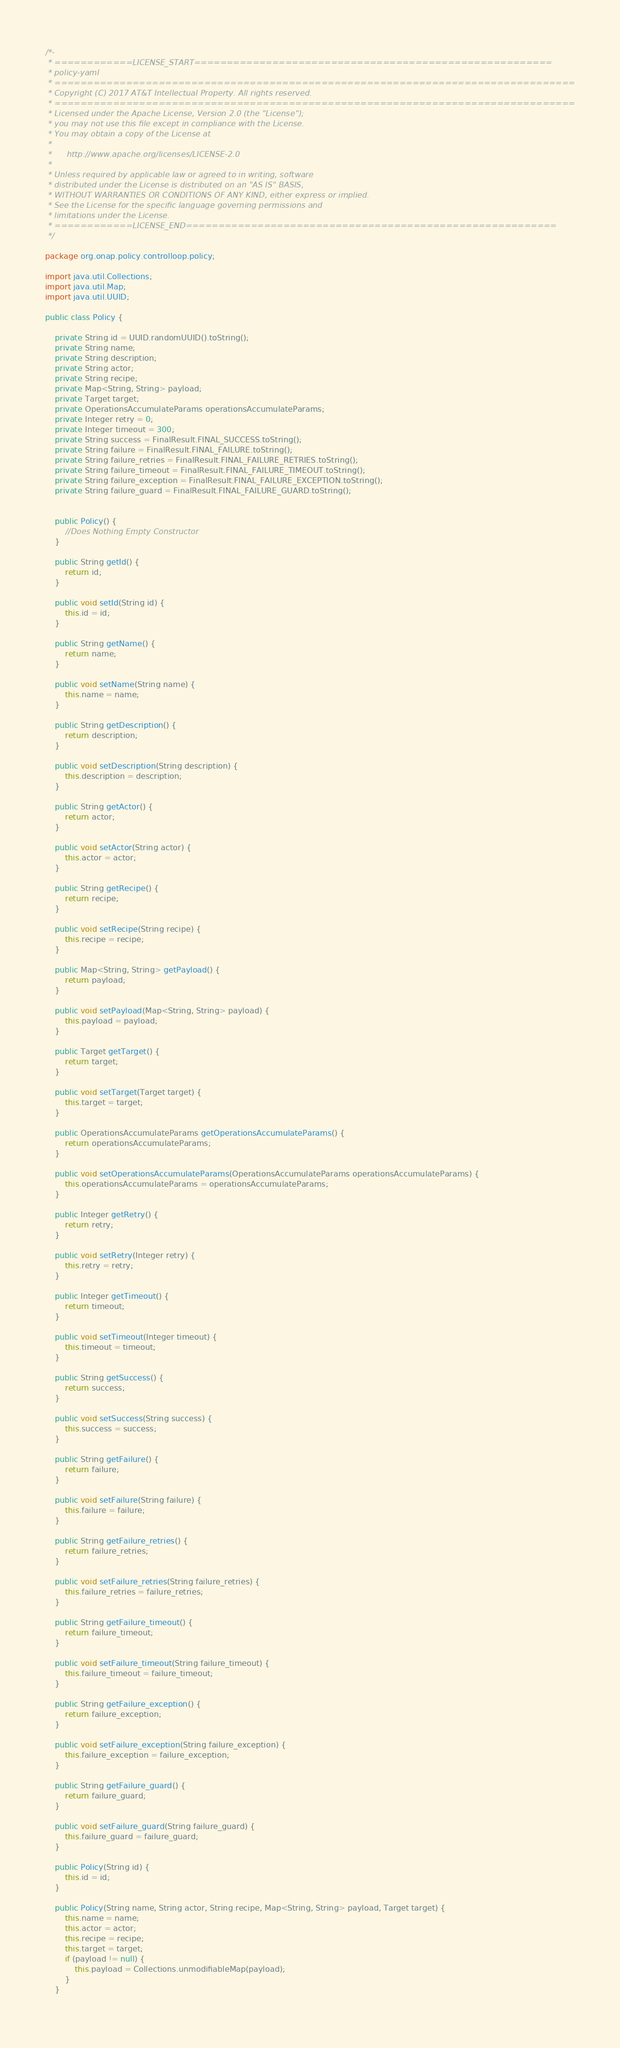<code> <loc_0><loc_0><loc_500><loc_500><_Java_>/*-
 * ============LICENSE_START=======================================================
 * policy-yaml
 * ================================================================================
 * Copyright (C) 2017 AT&T Intellectual Property. All rights reserved.
 * ================================================================================
 * Licensed under the Apache License, Version 2.0 (the "License");
 * you may not use this file except in compliance with the License.
 * You may obtain a copy of the License at
 * 
 *      http://www.apache.org/licenses/LICENSE-2.0
 * 
 * Unless required by applicable law or agreed to in writing, software
 * distributed under the License is distributed on an "AS IS" BASIS,
 * WITHOUT WARRANTIES OR CONDITIONS OF ANY KIND, either express or implied.
 * See the License for the specific language governing permissions and
 * limitations under the License.
 * ============LICENSE_END=========================================================
 */

package org.onap.policy.controlloop.policy;

import java.util.Collections;
import java.util.Map;
import java.util.UUID;

public class Policy {

    private String id = UUID.randomUUID().toString();
    private String name;
    private String description;
    private String actor;
    private String recipe;
    private Map<String, String> payload;
    private Target target;
    private OperationsAccumulateParams operationsAccumulateParams;
    private Integer retry = 0;
    private Integer timeout = 300;
    private String success = FinalResult.FINAL_SUCCESS.toString();
    private String failure = FinalResult.FINAL_FAILURE.toString();
    private String failure_retries = FinalResult.FINAL_FAILURE_RETRIES.toString();
    private String failure_timeout = FinalResult.FINAL_FAILURE_TIMEOUT.toString();
    private String failure_exception = FinalResult.FINAL_FAILURE_EXCEPTION.toString();
    private String failure_guard = FinalResult.FINAL_FAILURE_GUARD.toString();
    
    
    public Policy() {
        //Does Nothing Empty Constructor
    }
    
    public String getId() {
        return id;
    }

    public void setId(String id) {
        this.id = id;
    }

    public String getName() {
        return name;
    }

    public void setName(String name) {
        this.name = name;
    }

    public String getDescription() {
        return description;
    }

    public void setDescription(String description) {
        this.description = description;
    }

    public String getActor() {
        return actor;
    }

    public void setActor(String actor) {
        this.actor = actor;
    }

    public String getRecipe() {
        return recipe;
    }

    public void setRecipe(String recipe) {
        this.recipe = recipe;
    }

    public Map<String, String> getPayload() {
        return payload;
    }

    public void setPayload(Map<String, String> payload) {
        this.payload = payload;
    }

    public Target getTarget() {
        return target;
    }

    public void setTarget(Target target) {
        this.target = target;
    }

    public OperationsAccumulateParams getOperationsAccumulateParams() {
        return operationsAccumulateParams;
    }

    public void setOperationsAccumulateParams(OperationsAccumulateParams operationsAccumulateParams) {
        this.operationsAccumulateParams = operationsAccumulateParams;
    }

    public Integer getRetry() {
        return retry;
    }

    public void setRetry(Integer retry) {
        this.retry = retry;
    }

    public Integer getTimeout() {
        return timeout;
    }

    public void setTimeout(Integer timeout) {
        this.timeout = timeout;
    }

    public String getSuccess() {
        return success;
    }

    public void setSuccess(String success) {
        this.success = success;
    }

    public String getFailure() {
        return failure;
    }

    public void setFailure(String failure) {
        this.failure = failure;
    }

    public String getFailure_retries() {
        return failure_retries;
    }

    public void setFailure_retries(String failure_retries) {
        this.failure_retries = failure_retries;
    }

    public String getFailure_timeout() {
        return failure_timeout;
    }

    public void setFailure_timeout(String failure_timeout) {
        this.failure_timeout = failure_timeout;
    }

    public String getFailure_exception() {
        return failure_exception;
    }

    public void setFailure_exception(String failure_exception) {
        this.failure_exception = failure_exception;
    }

    public String getFailure_guard() {
        return failure_guard;
    }

    public void setFailure_guard(String failure_guard) {
        this.failure_guard = failure_guard;
    }

    public Policy(String id) {
        this.id = id;
    }
    
    public Policy(String name, String actor, String recipe, Map<String, String> payload, Target target) {
        this.name = name;
        this.actor = actor;
        this.recipe = recipe;
        this.target = target;
        if (payload != null) {
            this.payload = Collections.unmodifiableMap(payload);
        }
    }
    </code> 